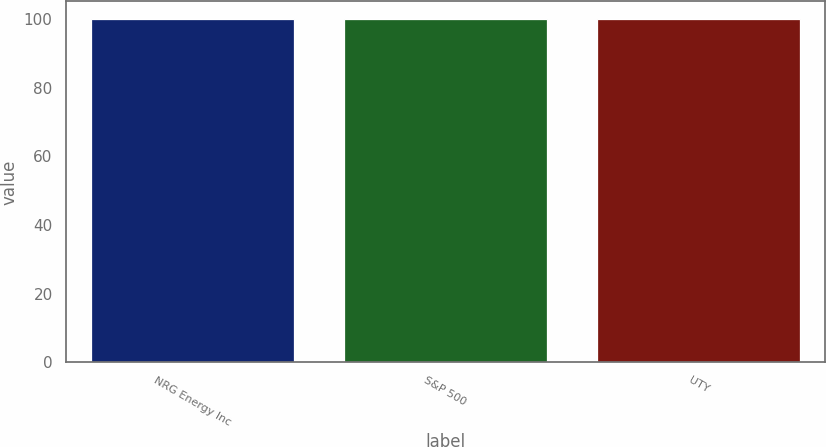<chart> <loc_0><loc_0><loc_500><loc_500><bar_chart><fcel>NRG Energy Inc<fcel>S&P 500<fcel>UTY<nl><fcel>100<fcel>100.1<fcel>100.2<nl></chart> 